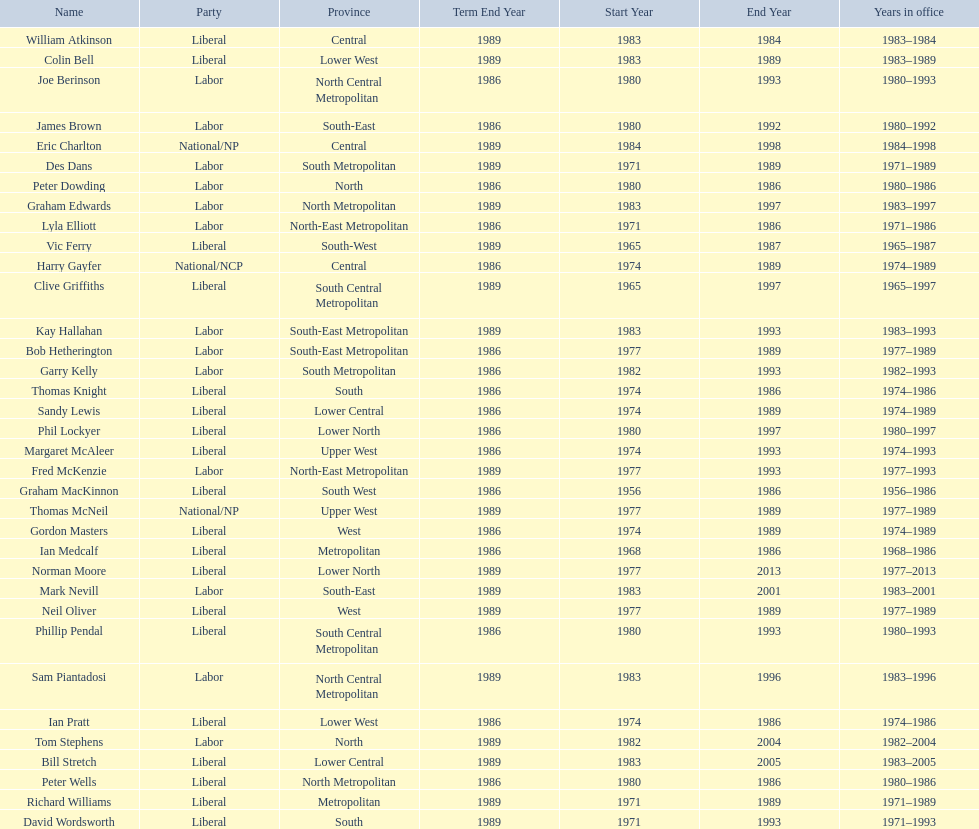Who has had the shortest term in office William Atkinson. 